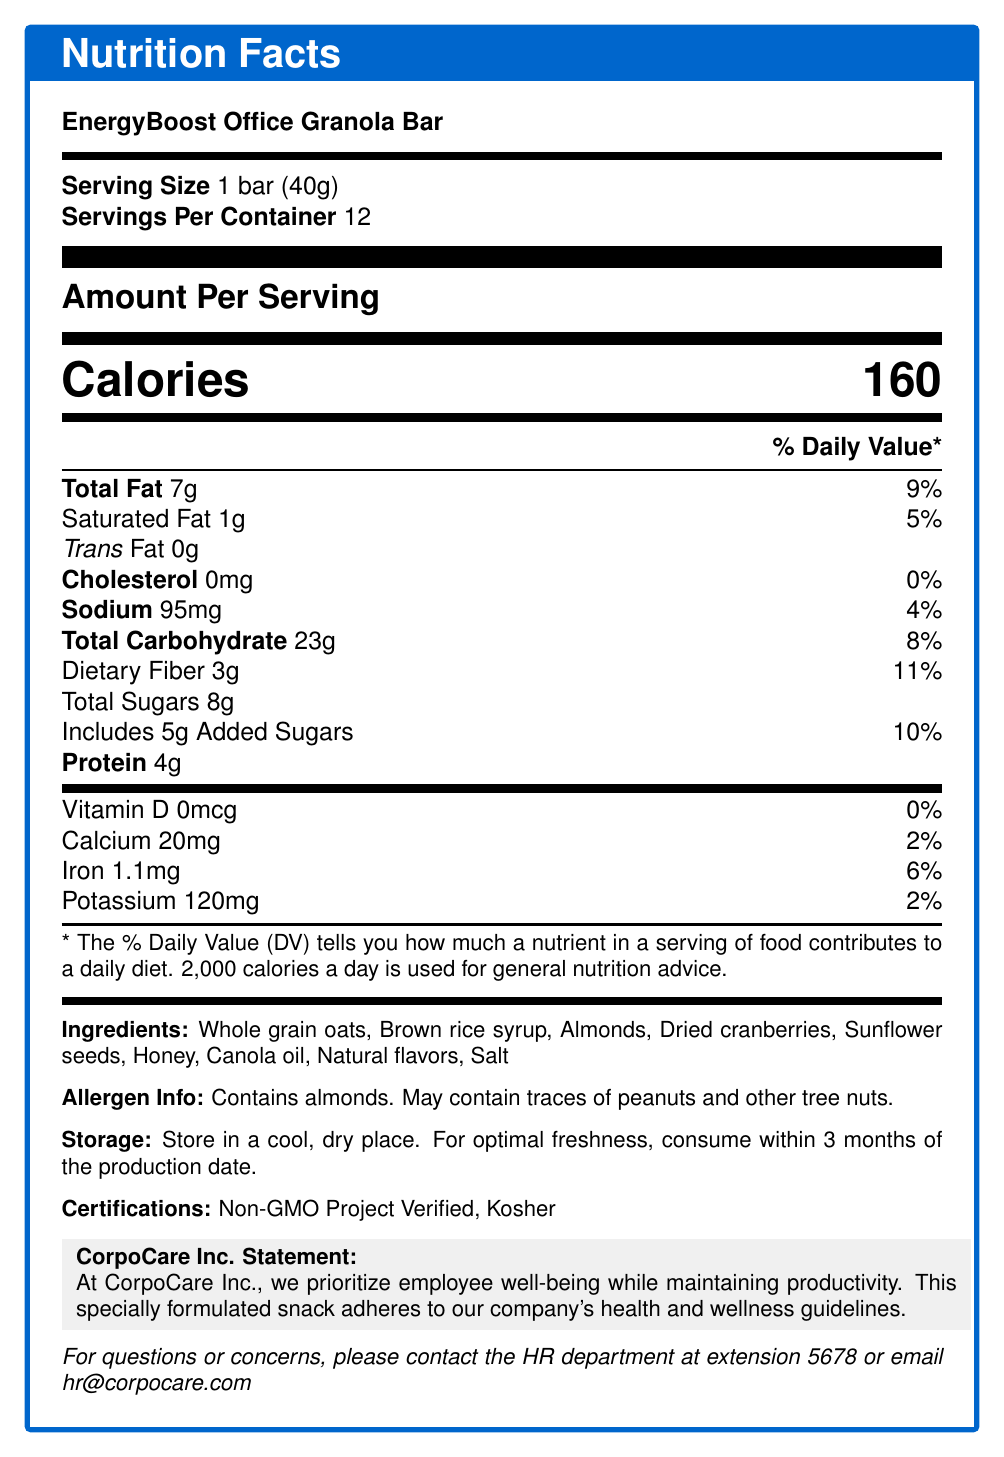what is the serving size for this product? According to the document, the serving size is clearly stated as 1 bar (40g).
Answer: 1 bar (40g) how much protein does one serving of this product contain? The "Protein" content is specified as 4g per serving.
Answer: 4g what is the total fat content per serving? The "Total Fat" content per serving is listed as 7g.
Answer: 7g what certifications does this product have? The document lists "Non-GMO Project Verified" and "Kosher" under Certifications.
Answer: Non-GMO Project Verified, Kosher how many servings are there per container? The document states that there are 12 servings per container.
Answer: 12 what is the main ingredient in this product? A. Whole grain oats B. Honey C. Brown rice syrup The first ingredient listed is "Whole grain oats," which typically indicates it is the main ingredient.
Answer: A. Whole grain oats how much calcium is in one serving of this product? A. 0mg B. 20mg C. 120mg The document states that each serving contains 20mg of calcium.
Answer: B. 20mg does this product contain any allergens? The document specifies that the product contains almonds and may contain traces of peanuts and other tree nuts.
Answer: Yes is vitamin D present in this product? According to the document, the product contains 0mcg (0%) Vitamin D, indicating it is not present.
Answer: No summarize the main features of this product as detailed in the document. The document highlights the main features, including nutritional information, ingredients, allergen info, certifications, and storage instructions.
Answer: The EnergyBoost Office Granola Bar is a healthy snack option with 160 calories per serving, containing whole grain oats, almonds, and dried cranberries. It's Non-GMO Project Verified and Kosher, adheres to health and wellness guidelines, and should be stored in a cool, dry place. what are the potential allergens in this product? The document details that the product contains almonds and may contain traces of peanuts and other tree nuts.
Answer: Almonds, peanuts (traces), other tree nuts (traces) what percentage of daily fiber is provided by one serving of this product? The document specifies that one serving provides 11% of the daily value for dietary fiber.
Answer: 11% how many grams of added sugars are there per serving? According to the document, there are 5g of added sugars per serving.
Answer: 5g how many calories are there in one bar of the EnergyBoost Office Granola Bar? The document explicitly states that one bar contains 160 calories.
Answer: 160 how much iron is in one serving of this product? The document lists 1.1mg of iron per serving.
Answer: 1.1mg what storage instructions are provided for this product? The document provides specific storage instructions to maintain the freshness of the product.
Answer: Store in a cool, dry place. For optimal freshness, consume within 3 months of the production date. what is the company statement regarding this product's formulation? The document includes a statement from CorpoCare Inc. detailing the purpose and adherence to health guidelines.
Answer: At CorpoCare Inc., we prioritize employee well-being while maintaining productivity. This specially formulated snack adheres to our company's health and wellness guidelines. is the product suitable for those following a gluten-free diet? The document does not specify whether the product is gluten-free or not.
Answer: Not enough information who should be contacted for questions or concerns about this product? The document provides contact information for the HR department for any questions or concerns.
Answer: HR department at extension 5678 or email hr@corpocare.com 